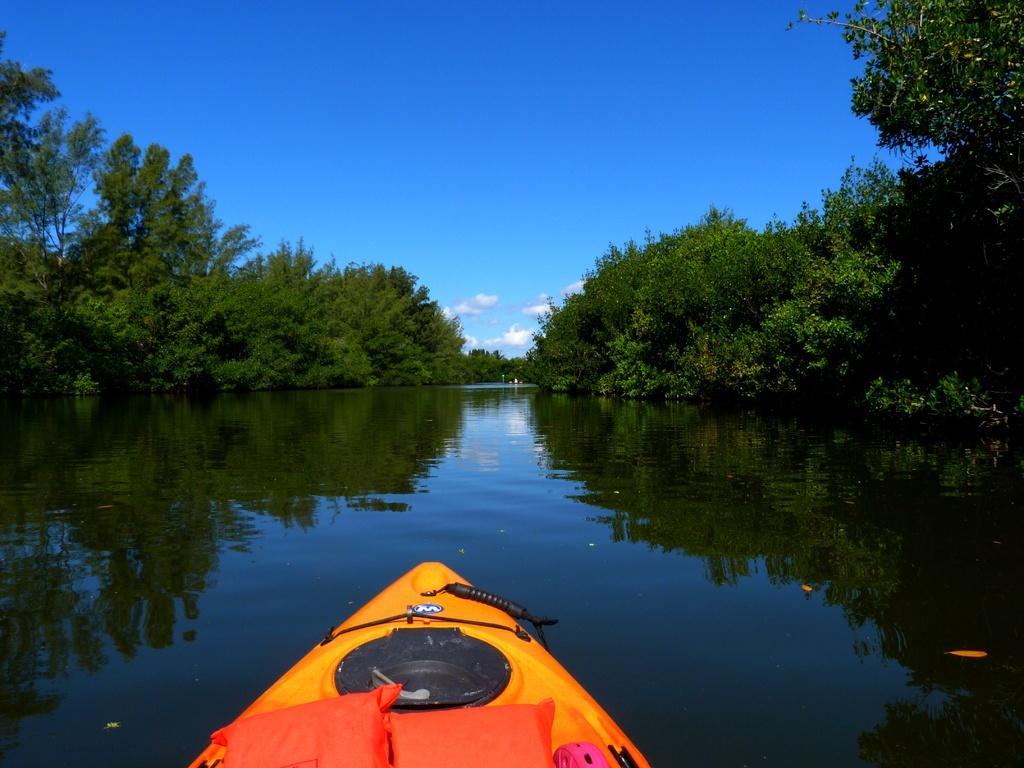Could you give a brief overview of what you see in this image? In this picture we can see pillows and some objects on a boat and this boat is on water and in the background we can see trees, sky with clouds. 